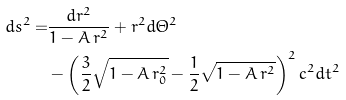Convert formula to latex. <formula><loc_0><loc_0><loc_500><loc_500>d s ^ { 2 } = & \frac { d r ^ { 2 } } { 1 - A \, r ^ { 2 } } + r ^ { 2 } d \Theta ^ { 2 } \\ & - \left ( \frac { 3 } { 2 } \sqrt { 1 - A \, r _ { 0 } ^ { 2 } } - \frac { 1 } { 2 } \sqrt { 1 - A \, r ^ { 2 } } \right ) ^ { 2 } c ^ { 2 } d t ^ { 2 }</formula> 